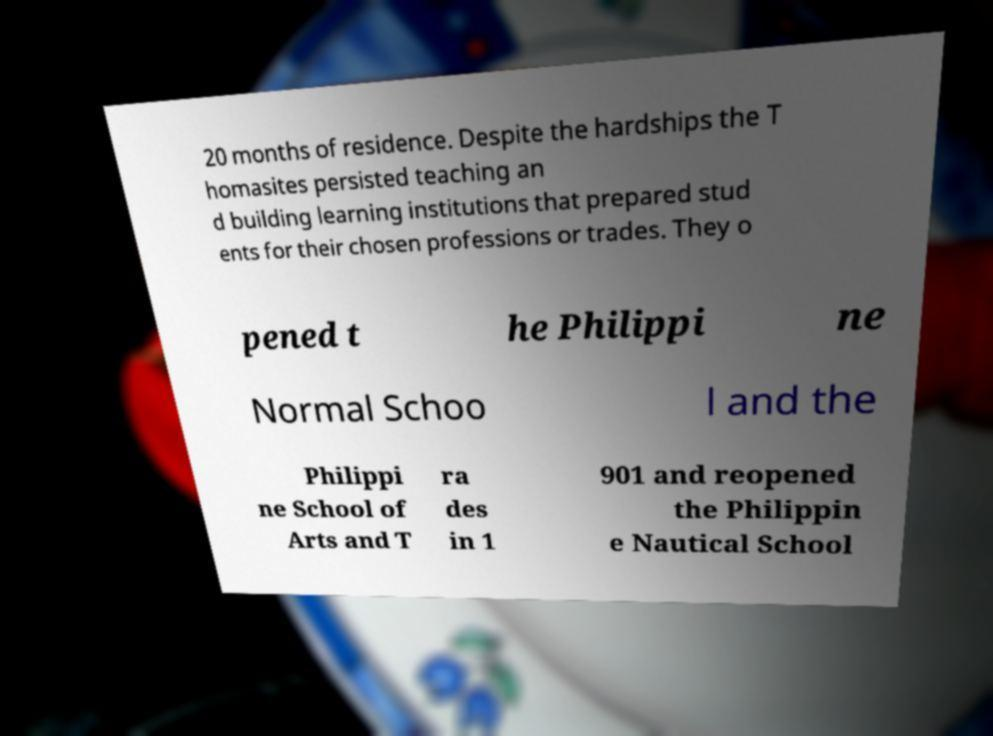Could you assist in decoding the text presented in this image and type it out clearly? 20 months of residence. Despite the hardships the T homasites persisted teaching an d building learning institutions that prepared stud ents for their chosen professions or trades. They o pened t he Philippi ne Normal Schoo l and the Philippi ne School of Arts and T ra des in 1 901 and reopened the Philippin e Nautical School 